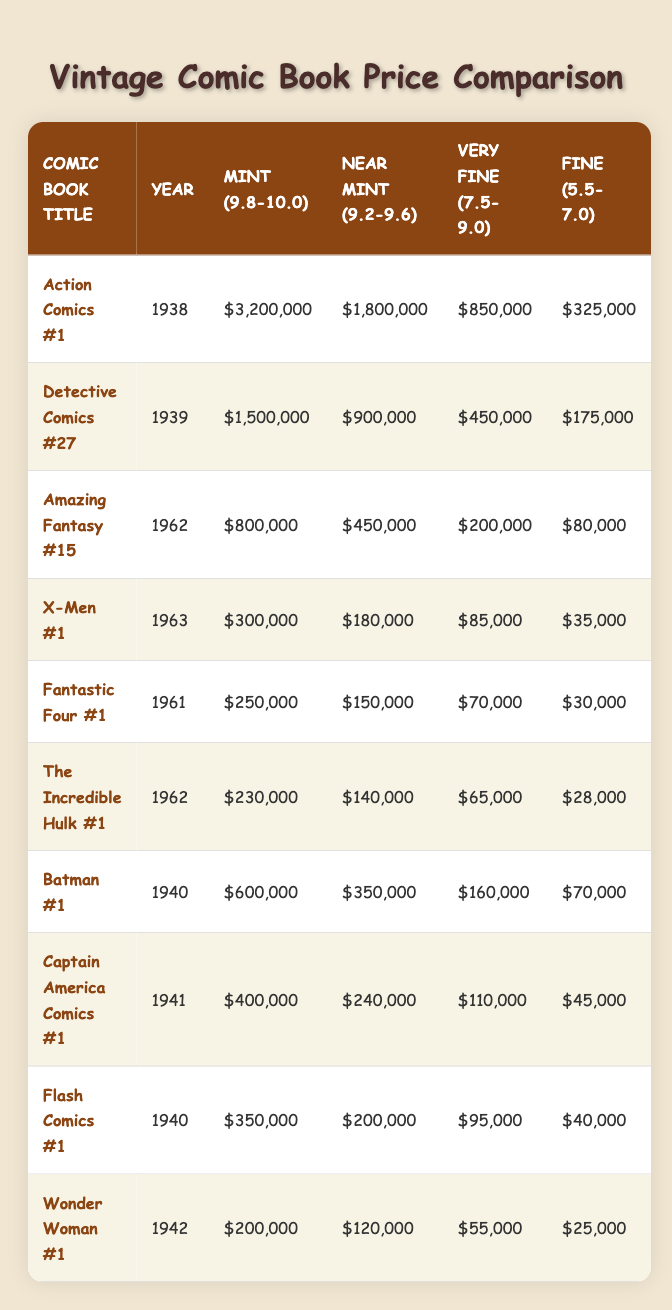What is the price of Action Comics #1 in Mint condition? The table shows that the price of Action Comics #1 in Mint (9.8-10.0) condition is $3,200,000.
Answer: $3,200,000 In what year was Detective Comics #27 released? The table indicates that Detective Comics #27 was released in the year 1939.
Answer: 1939 Which comic has the lowest price in Fine condition? By comparing the Fine condition prices across all comics, Wonder Woman #1 has the lowest price at $25,000.
Answer: $25,000 What is the difference in price between the Mint and Near Mint condition of Amazing Fantasy #15? The Mint price for Amazing Fantasy #15 is $800,000 and the Near Mint price is $450,000. The difference is calculated as $800,000 - $450,000 = $350,000.
Answer: $350,000 True or False: X-Men #1 has a higher price in Near Mint condition than Fantastic Four #1. The table shows that the price of X-Men #1 in Near Mint condition is $180,000 while Fantastic Four #1 is priced at $150,000. Since $180,000 > $150,000, the statement is true.
Answer: True What is the average price of all the comics listed in Fine condition? To find the average price in Fine condition, we sum the prices: $325,000 + $175,000 + $80,000 + $35,000 + $30,000 + $28,000 + $70,000 + $45,000 + $40,000 + $25,000 = $878,000. Dividing by the total number of comics (10) gives an average of $878,000 / 10 = $87,800.
Answer: $87,800 Which comic book holds the highest value in Very Fine condition? The table shows Action Comics #1 valued at $850,000 in Very Fine condition, which is higher than any other comic's price in that category.
Answer: Action Comics #1 How much more is the price of Batman #1 in Mint condition compared to Captain America Comics #1 in the same condition? The price for Batman #1 in Mint condition is $600,000 and for Captain America Comics #1, it is $400,000. The difference is $600,000 - $400,000 = $200,000.
Answer: $200,000 Is the price for Flash Comics #1 in Near Mint condition greater than $200,000? The table shows the price of Flash Comics #1 in Near Mint is $200,000. Since it is not greater than $200,000, the statement is false.
Answer: False 